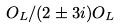Convert formula to latex. <formula><loc_0><loc_0><loc_500><loc_500>O _ { L } / ( 2 \pm 3 i ) O _ { L }</formula> 